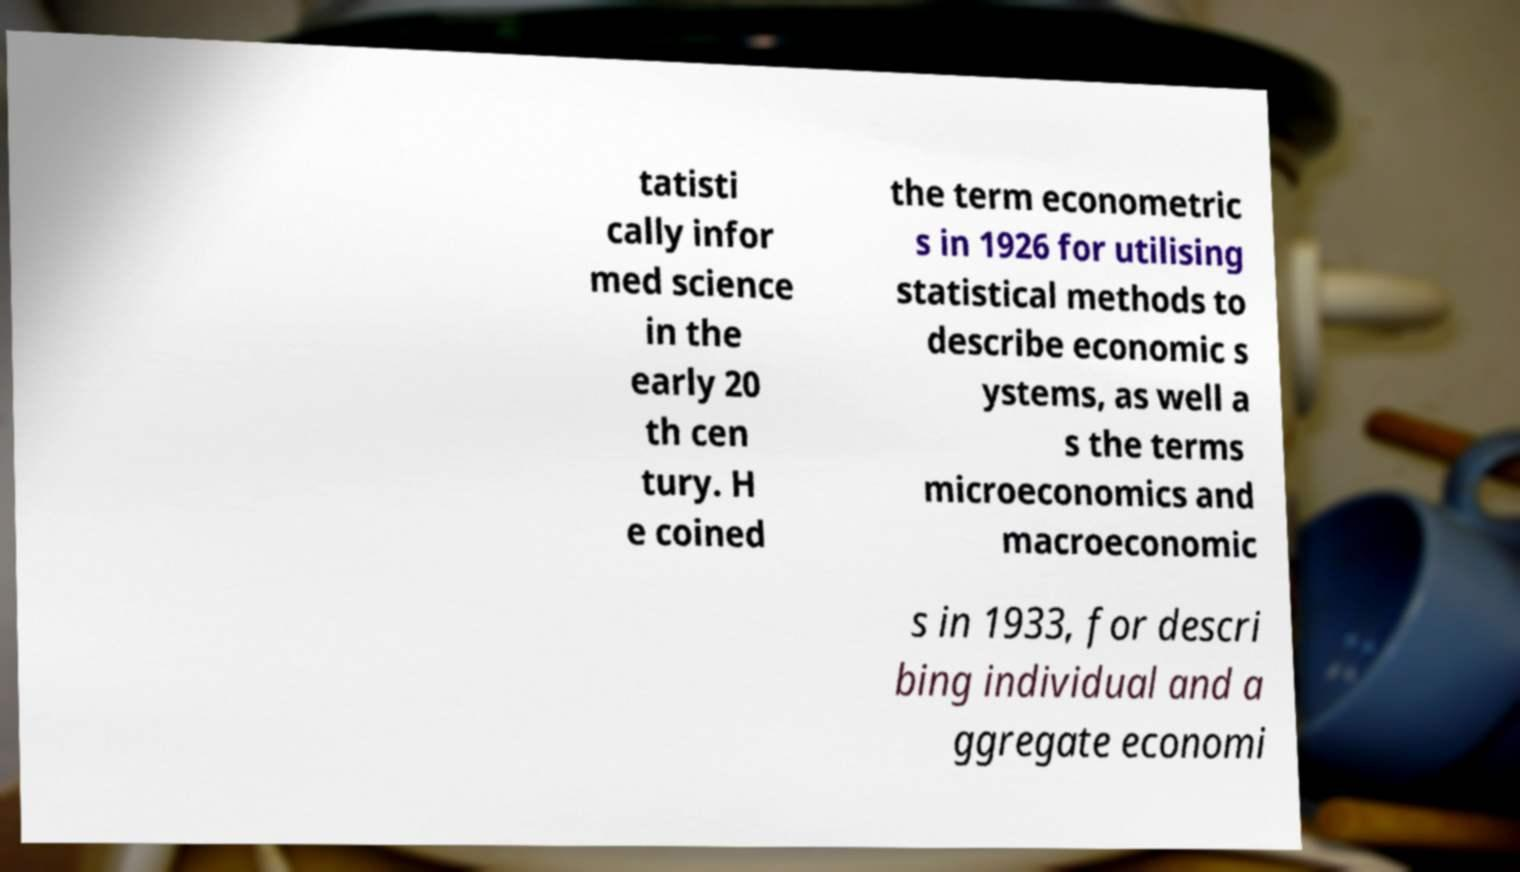For documentation purposes, I need the text within this image transcribed. Could you provide that? tatisti cally infor med science in the early 20 th cen tury. H e coined the term econometric s in 1926 for utilising statistical methods to describe economic s ystems, as well a s the terms microeconomics and macroeconomic s in 1933, for descri bing individual and a ggregate economi 